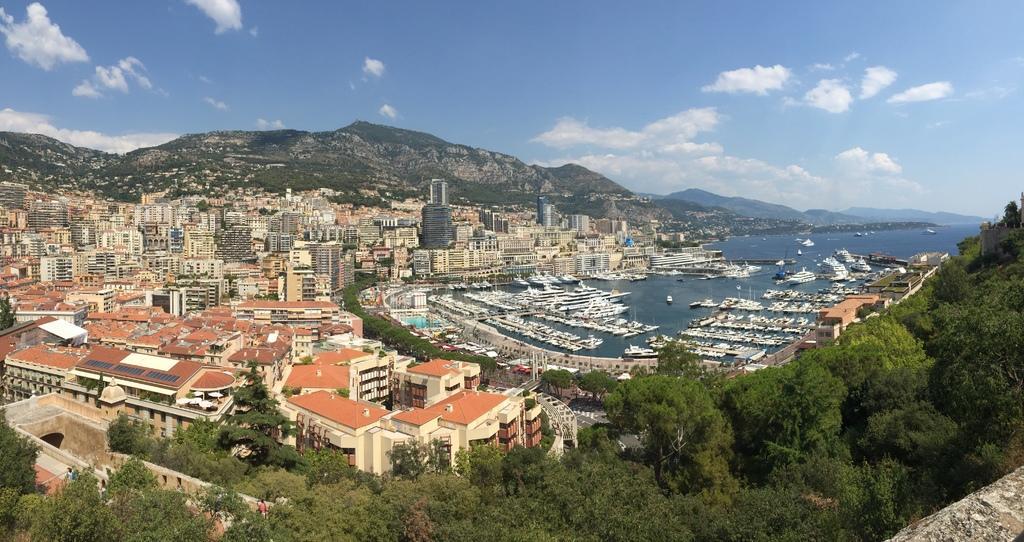In one or two sentences, can you explain what this image depicts? In this image we can see buildings with windows, mountains, trees and in the background we can see the sky. 